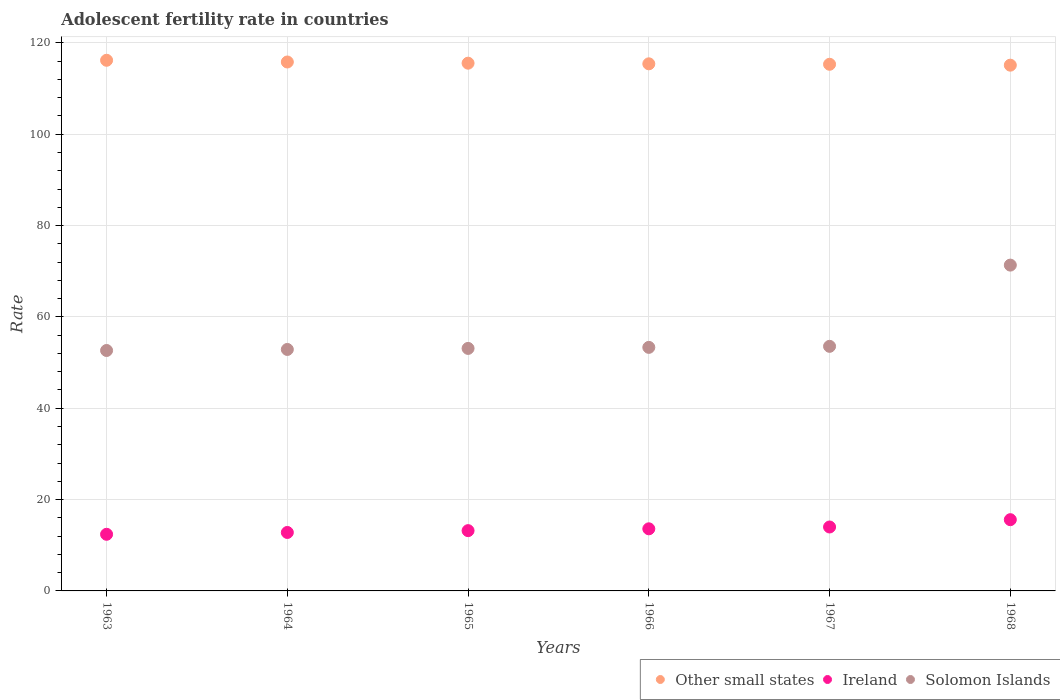How many different coloured dotlines are there?
Give a very brief answer. 3. Is the number of dotlines equal to the number of legend labels?
Offer a terse response. Yes. What is the adolescent fertility rate in Other small states in 1965?
Make the answer very short. 115.55. Across all years, what is the maximum adolescent fertility rate in Solomon Islands?
Keep it short and to the point. 71.34. Across all years, what is the minimum adolescent fertility rate in Ireland?
Ensure brevity in your answer.  12.4. In which year was the adolescent fertility rate in Other small states minimum?
Keep it short and to the point. 1968. What is the total adolescent fertility rate in Other small states in the graph?
Provide a short and direct response. 693.4. What is the difference between the adolescent fertility rate in Other small states in 1964 and that in 1966?
Your answer should be compact. 0.4. What is the difference between the adolescent fertility rate in Other small states in 1966 and the adolescent fertility rate in Ireland in 1964?
Make the answer very short. 102.61. What is the average adolescent fertility rate in Ireland per year?
Offer a terse response. 13.6. In the year 1968, what is the difference between the adolescent fertility rate in Other small states and adolescent fertility rate in Ireland?
Provide a succinct answer. 99.52. What is the ratio of the adolescent fertility rate in Ireland in 1963 to that in 1965?
Provide a succinct answer. 0.94. What is the difference between the highest and the second highest adolescent fertility rate in Solomon Islands?
Offer a terse response. 17.78. What is the difference between the highest and the lowest adolescent fertility rate in Ireland?
Keep it short and to the point. 3.2. How many years are there in the graph?
Your answer should be very brief. 6. Are the values on the major ticks of Y-axis written in scientific E-notation?
Ensure brevity in your answer.  No. Where does the legend appear in the graph?
Provide a succinct answer. Bottom right. How many legend labels are there?
Your answer should be compact. 3. What is the title of the graph?
Make the answer very short. Adolescent fertility rate in countries. What is the label or title of the X-axis?
Ensure brevity in your answer.  Years. What is the label or title of the Y-axis?
Your answer should be compact. Rate. What is the Rate of Other small states in 1963?
Give a very brief answer. 116.19. What is the Rate of Ireland in 1963?
Provide a short and direct response. 12.4. What is the Rate in Solomon Islands in 1963?
Your answer should be compact. 52.64. What is the Rate of Other small states in 1964?
Keep it short and to the point. 115.81. What is the Rate in Ireland in 1964?
Your answer should be compact. 12.8. What is the Rate in Solomon Islands in 1964?
Your answer should be compact. 52.87. What is the Rate of Other small states in 1965?
Make the answer very short. 115.55. What is the Rate of Ireland in 1965?
Your response must be concise. 13.2. What is the Rate in Solomon Islands in 1965?
Give a very brief answer. 53.1. What is the Rate in Other small states in 1966?
Your response must be concise. 115.41. What is the Rate of Ireland in 1966?
Offer a terse response. 13.6. What is the Rate in Solomon Islands in 1966?
Your answer should be compact. 53.33. What is the Rate of Other small states in 1967?
Give a very brief answer. 115.31. What is the Rate of Ireland in 1967?
Offer a terse response. 14. What is the Rate of Solomon Islands in 1967?
Your response must be concise. 53.55. What is the Rate of Other small states in 1968?
Make the answer very short. 115.12. What is the Rate in Ireland in 1968?
Offer a terse response. 15.6. What is the Rate in Solomon Islands in 1968?
Offer a terse response. 71.34. Across all years, what is the maximum Rate of Other small states?
Your answer should be very brief. 116.19. Across all years, what is the maximum Rate of Ireland?
Provide a short and direct response. 15.6. Across all years, what is the maximum Rate of Solomon Islands?
Give a very brief answer. 71.34. Across all years, what is the minimum Rate in Other small states?
Offer a terse response. 115.12. Across all years, what is the minimum Rate of Ireland?
Your response must be concise. 12.4. Across all years, what is the minimum Rate of Solomon Islands?
Give a very brief answer. 52.64. What is the total Rate of Other small states in the graph?
Provide a short and direct response. 693.4. What is the total Rate in Ireland in the graph?
Offer a terse response. 81.59. What is the total Rate in Solomon Islands in the graph?
Offer a terse response. 336.83. What is the difference between the Rate in Other small states in 1963 and that in 1964?
Give a very brief answer. 0.37. What is the difference between the Rate of Ireland in 1963 and that in 1964?
Offer a terse response. -0.4. What is the difference between the Rate in Solomon Islands in 1963 and that in 1964?
Keep it short and to the point. -0.23. What is the difference between the Rate of Other small states in 1963 and that in 1965?
Ensure brevity in your answer.  0.64. What is the difference between the Rate of Ireland in 1963 and that in 1965?
Ensure brevity in your answer.  -0.8. What is the difference between the Rate of Solomon Islands in 1963 and that in 1965?
Your answer should be very brief. -0.46. What is the difference between the Rate of Other small states in 1963 and that in 1966?
Ensure brevity in your answer.  0.77. What is the difference between the Rate of Ireland in 1963 and that in 1966?
Your answer should be very brief. -1.2. What is the difference between the Rate in Solomon Islands in 1963 and that in 1966?
Provide a succinct answer. -0.68. What is the difference between the Rate of Other small states in 1963 and that in 1967?
Offer a terse response. 0.88. What is the difference between the Rate in Ireland in 1963 and that in 1967?
Give a very brief answer. -1.6. What is the difference between the Rate in Solomon Islands in 1963 and that in 1967?
Your answer should be very brief. -0.91. What is the difference between the Rate of Other small states in 1963 and that in 1968?
Give a very brief answer. 1.07. What is the difference between the Rate in Ireland in 1963 and that in 1968?
Provide a short and direct response. -3.2. What is the difference between the Rate in Solomon Islands in 1963 and that in 1968?
Your answer should be very brief. -18.7. What is the difference between the Rate in Other small states in 1964 and that in 1965?
Make the answer very short. 0.26. What is the difference between the Rate of Ireland in 1964 and that in 1965?
Offer a terse response. -0.4. What is the difference between the Rate in Solomon Islands in 1964 and that in 1965?
Give a very brief answer. -0.23. What is the difference between the Rate in Other small states in 1964 and that in 1966?
Your answer should be very brief. 0.4. What is the difference between the Rate in Ireland in 1964 and that in 1966?
Provide a short and direct response. -0.8. What is the difference between the Rate of Solomon Islands in 1964 and that in 1966?
Keep it short and to the point. -0.46. What is the difference between the Rate in Other small states in 1964 and that in 1967?
Provide a succinct answer. 0.5. What is the difference between the Rate of Ireland in 1964 and that in 1967?
Keep it short and to the point. -1.2. What is the difference between the Rate of Solomon Islands in 1964 and that in 1967?
Provide a short and direct response. -0.68. What is the difference between the Rate of Other small states in 1964 and that in 1968?
Give a very brief answer. 0.7. What is the difference between the Rate in Ireland in 1964 and that in 1968?
Your response must be concise. -2.8. What is the difference between the Rate of Solomon Islands in 1964 and that in 1968?
Provide a short and direct response. -18.47. What is the difference between the Rate in Other small states in 1965 and that in 1966?
Give a very brief answer. 0.14. What is the difference between the Rate in Ireland in 1965 and that in 1966?
Offer a terse response. -0.4. What is the difference between the Rate in Solomon Islands in 1965 and that in 1966?
Provide a short and direct response. -0.23. What is the difference between the Rate of Other small states in 1965 and that in 1967?
Offer a terse response. 0.24. What is the difference between the Rate in Ireland in 1965 and that in 1967?
Your answer should be very brief. -0.8. What is the difference between the Rate in Solomon Islands in 1965 and that in 1967?
Your answer should be very brief. -0.46. What is the difference between the Rate of Other small states in 1965 and that in 1968?
Make the answer very short. 0.44. What is the difference between the Rate of Ireland in 1965 and that in 1968?
Provide a succinct answer. -2.4. What is the difference between the Rate of Solomon Islands in 1965 and that in 1968?
Offer a very short reply. -18.24. What is the difference between the Rate in Other small states in 1966 and that in 1967?
Offer a terse response. 0.1. What is the difference between the Rate of Ireland in 1966 and that in 1967?
Your response must be concise. -0.4. What is the difference between the Rate in Solomon Islands in 1966 and that in 1967?
Your response must be concise. -0.23. What is the difference between the Rate of Other small states in 1966 and that in 1968?
Offer a very short reply. 0.3. What is the difference between the Rate in Ireland in 1966 and that in 1968?
Keep it short and to the point. -2. What is the difference between the Rate of Solomon Islands in 1966 and that in 1968?
Provide a short and direct response. -18.01. What is the difference between the Rate in Other small states in 1967 and that in 1968?
Make the answer very short. 0.2. What is the difference between the Rate of Ireland in 1967 and that in 1968?
Provide a short and direct response. -1.6. What is the difference between the Rate of Solomon Islands in 1967 and that in 1968?
Offer a very short reply. -17.78. What is the difference between the Rate in Other small states in 1963 and the Rate in Ireland in 1964?
Offer a very short reply. 103.39. What is the difference between the Rate in Other small states in 1963 and the Rate in Solomon Islands in 1964?
Provide a short and direct response. 63.32. What is the difference between the Rate of Ireland in 1963 and the Rate of Solomon Islands in 1964?
Provide a short and direct response. -40.47. What is the difference between the Rate in Other small states in 1963 and the Rate in Ireland in 1965?
Give a very brief answer. 102.99. What is the difference between the Rate in Other small states in 1963 and the Rate in Solomon Islands in 1965?
Provide a short and direct response. 63.09. What is the difference between the Rate in Ireland in 1963 and the Rate in Solomon Islands in 1965?
Keep it short and to the point. -40.7. What is the difference between the Rate of Other small states in 1963 and the Rate of Ireland in 1966?
Provide a short and direct response. 102.59. What is the difference between the Rate of Other small states in 1963 and the Rate of Solomon Islands in 1966?
Provide a short and direct response. 62.86. What is the difference between the Rate of Ireland in 1963 and the Rate of Solomon Islands in 1966?
Offer a terse response. -40.93. What is the difference between the Rate of Other small states in 1963 and the Rate of Ireland in 1967?
Make the answer very short. 102.19. What is the difference between the Rate of Other small states in 1963 and the Rate of Solomon Islands in 1967?
Provide a short and direct response. 62.63. What is the difference between the Rate in Ireland in 1963 and the Rate in Solomon Islands in 1967?
Your answer should be very brief. -41.15. What is the difference between the Rate of Other small states in 1963 and the Rate of Ireland in 1968?
Offer a very short reply. 100.59. What is the difference between the Rate of Other small states in 1963 and the Rate of Solomon Islands in 1968?
Your answer should be very brief. 44.85. What is the difference between the Rate of Ireland in 1963 and the Rate of Solomon Islands in 1968?
Offer a very short reply. -58.94. What is the difference between the Rate in Other small states in 1964 and the Rate in Ireland in 1965?
Your answer should be compact. 102.61. What is the difference between the Rate of Other small states in 1964 and the Rate of Solomon Islands in 1965?
Your response must be concise. 62.71. What is the difference between the Rate of Ireland in 1964 and the Rate of Solomon Islands in 1965?
Make the answer very short. -40.3. What is the difference between the Rate in Other small states in 1964 and the Rate in Ireland in 1966?
Ensure brevity in your answer.  102.22. What is the difference between the Rate of Other small states in 1964 and the Rate of Solomon Islands in 1966?
Your response must be concise. 62.49. What is the difference between the Rate of Ireland in 1964 and the Rate of Solomon Islands in 1966?
Your response must be concise. -40.53. What is the difference between the Rate in Other small states in 1964 and the Rate in Ireland in 1967?
Your answer should be very brief. 101.82. What is the difference between the Rate in Other small states in 1964 and the Rate in Solomon Islands in 1967?
Provide a succinct answer. 62.26. What is the difference between the Rate of Ireland in 1964 and the Rate of Solomon Islands in 1967?
Provide a short and direct response. -40.75. What is the difference between the Rate in Other small states in 1964 and the Rate in Ireland in 1968?
Keep it short and to the point. 100.22. What is the difference between the Rate of Other small states in 1964 and the Rate of Solomon Islands in 1968?
Your answer should be very brief. 44.48. What is the difference between the Rate of Ireland in 1964 and the Rate of Solomon Islands in 1968?
Offer a terse response. -58.54. What is the difference between the Rate of Other small states in 1965 and the Rate of Ireland in 1966?
Your answer should be very brief. 101.95. What is the difference between the Rate in Other small states in 1965 and the Rate in Solomon Islands in 1966?
Provide a short and direct response. 62.23. What is the difference between the Rate in Ireland in 1965 and the Rate in Solomon Islands in 1966?
Provide a short and direct response. -40.13. What is the difference between the Rate in Other small states in 1965 and the Rate in Ireland in 1967?
Your response must be concise. 101.55. What is the difference between the Rate in Other small states in 1965 and the Rate in Solomon Islands in 1967?
Ensure brevity in your answer.  62. What is the difference between the Rate in Ireland in 1965 and the Rate in Solomon Islands in 1967?
Provide a short and direct response. -40.36. What is the difference between the Rate in Other small states in 1965 and the Rate in Ireland in 1968?
Provide a succinct answer. 99.95. What is the difference between the Rate of Other small states in 1965 and the Rate of Solomon Islands in 1968?
Offer a very short reply. 44.21. What is the difference between the Rate of Ireland in 1965 and the Rate of Solomon Islands in 1968?
Ensure brevity in your answer.  -58.14. What is the difference between the Rate in Other small states in 1966 and the Rate in Ireland in 1967?
Your response must be concise. 101.42. What is the difference between the Rate of Other small states in 1966 and the Rate of Solomon Islands in 1967?
Give a very brief answer. 61.86. What is the difference between the Rate of Ireland in 1966 and the Rate of Solomon Islands in 1967?
Provide a succinct answer. -39.96. What is the difference between the Rate in Other small states in 1966 and the Rate in Ireland in 1968?
Ensure brevity in your answer.  99.82. What is the difference between the Rate in Other small states in 1966 and the Rate in Solomon Islands in 1968?
Provide a short and direct response. 44.08. What is the difference between the Rate in Ireland in 1966 and the Rate in Solomon Islands in 1968?
Ensure brevity in your answer.  -57.74. What is the difference between the Rate of Other small states in 1967 and the Rate of Ireland in 1968?
Provide a succinct answer. 99.72. What is the difference between the Rate in Other small states in 1967 and the Rate in Solomon Islands in 1968?
Keep it short and to the point. 43.97. What is the difference between the Rate of Ireland in 1967 and the Rate of Solomon Islands in 1968?
Keep it short and to the point. -57.34. What is the average Rate of Other small states per year?
Ensure brevity in your answer.  115.57. What is the average Rate of Ireland per year?
Give a very brief answer. 13.6. What is the average Rate of Solomon Islands per year?
Provide a short and direct response. 56.14. In the year 1963, what is the difference between the Rate of Other small states and Rate of Ireland?
Keep it short and to the point. 103.79. In the year 1963, what is the difference between the Rate of Other small states and Rate of Solomon Islands?
Keep it short and to the point. 63.54. In the year 1963, what is the difference between the Rate of Ireland and Rate of Solomon Islands?
Your response must be concise. -40.24. In the year 1964, what is the difference between the Rate in Other small states and Rate in Ireland?
Your answer should be compact. 103.01. In the year 1964, what is the difference between the Rate of Other small states and Rate of Solomon Islands?
Your answer should be very brief. 62.94. In the year 1964, what is the difference between the Rate of Ireland and Rate of Solomon Islands?
Offer a very short reply. -40.07. In the year 1965, what is the difference between the Rate in Other small states and Rate in Ireland?
Your answer should be compact. 102.35. In the year 1965, what is the difference between the Rate in Other small states and Rate in Solomon Islands?
Provide a short and direct response. 62.45. In the year 1965, what is the difference between the Rate in Ireland and Rate in Solomon Islands?
Keep it short and to the point. -39.9. In the year 1966, what is the difference between the Rate in Other small states and Rate in Ireland?
Keep it short and to the point. 101.82. In the year 1966, what is the difference between the Rate in Other small states and Rate in Solomon Islands?
Ensure brevity in your answer.  62.09. In the year 1966, what is the difference between the Rate in Ireland and Rate in Solomon Islands?
Make the answer very short. -39.73. In the year 1967, what is the difference between the Rate of Other small states and Rate of Ireland?
Provide a succinct answer. 101.31. In the year 1967, what is the difference between the Rate of Other small states and Rate of Solomon Islands?
Your response must be concise. 61.76. In the year 1967, what is the difference between the Rate in Ireland and Rate in Solomon Islands?
Your response must be concise. -39.56. In the year 1968, what is the difference between the Rate of Other small states and Rate of Ireland?
Keep it short and to the point. 99.52. In the year 1968, what is the difference between the Rate of Other small states and Rate of Solomon Islands?
Keep it short and to the point. 43.78. In the year 1968, what is the difference between the Rate in Ireland and Rate in Solomon Islands?
Your response must be concise. -55.74. What is the ratio of the Rate of Other small states in 1963 to that in 1964?
Make the answer very short. 1. What is the ratio of the Rate in Ireland in 1963 to that in 1964?
Make the answer very short. 0.97. What is the ratio of the Rate of Ireland in 1963 to that in 1965?
Offer a very short reply. 0.94. What is the ratio of the Rate in Solomon Islands in 1963 to that in 1965?
Give a very brief answer. 0.99. What is the ratio of the Rate of Ireland in 1963 to that in 1966?
Keep it short and to the point. 0.91. What is the ratio of the Rate in Solomon Islands in 1963 to that in 1966?
Give a very brief answer. 0.99. What is the ratio of the Rate of Other small states in 1963 to that in 1967?
Your answer should be compact. 1.01. What is the ratio of the Rate in Ireland in 1963 to that in 1967?
Provide a short and direct response. 0.89. What is the ratio of the Rate of Other small states in 1963 to that in 1968?
Your response must be concise. 1.01. What is the ratio of the Rate of Ireland in 1963 to that in 1968?
Offer a terse response. 0.8. What is the ratio of the Rate of Solomon Islands in 1963 to that in 1968?
Your response must be concise. 0.74. What is the ratio of the Rate of Ireland in 1964 to that in 1965?
Your answer should be compact. 0.97. What is the ratio of the Rate in Other small states in 1964 to that in 1967?
Ensure brevity in your answer.  1. What is the ratio of the Rate in Ireland in 1964 to that in 1967?
Your answer should be very brief. 0.91. What is the ratio of the Rate in Solomon Islands in 1964 to that in 1967?
Your response must be concise. 0.99. What is the ratio of the Rate in Other small states in 1964 to that in 1968?
Provide a short and direct response. 1.01. What is the ratio of the Rate in Ireland in 1964 to that in 1968?
Offer a very short reply. 0.82. What is the ratio of the Rate in Solomon Islands in 1964 to that in 1968?
Offer a very short reply. 0.74. What is the ratio of the Rate in Ireland in 1965 to that in 1966?
Offer a terse response. 0.97. What is the ratio of the Rate of Solomon Islands in 1965 to that in 1966?
Offer a terse response. 1. What is the ratio of the Rate of Other small states in 1965 to that in 1967?
Provide a short and direct response. 1. What is the ratio of the Rate of Ireland in 1965 to that in 1967?
Offer a terse response. 0.94. What is the ratio of the Rate of Solomon Islands in 1965 to that in 1967?
Your answer should be very brief. 0.99. What is the ratio of the Rate of Ireland in 1965 to that in 1968?
Give a very brief answer. 0.85. What is the ratio of the Rate of Solomon Islands in 1965 to that in 1968?
Ensure brevity in your answer.  0.74. What is the ratio of the Rate of Ireland in 1966 to that in 1967?
Make the answer very short. 0.97. What is the ratio of the Rate of Solomon Islands in 1966 to that in 1967?
Keep it short and to the point. 1. What is the ratio of the Rate in Ireland in 1966 to that in 1968?
Keep it short and to the point. 0.87. What is the ratio of the Rate in Solomon Islands in 1966 to that in 1968?
Your response must be concise. 0.75. What is the ratio of the Rate of Ireland in 1967 to that in 1968?
Offer a terse response. 0.9. What is the ratio of the Rate of Solomon Islands in 1967 to that in 1968?
Keep it short and to the point. 0.75. What is the difference between the highest and the second highest Rate of Other small states?
Keep it short and to the point. 0.37. What is the difference between the highest and the second highest Rate in Ireland?
Offer a very short reply. 1.6. What is the difference between the highest and the second highest Rate in Solomon Islands?
Offer a very short reply. 17.78. What is the difference between the highest and the lowest Rate of Other small states?
Provide a short and direct response. 1.07. What is the difference between the highest and the lowest Rate of Ireland?
Ensure brevity in your answer.  3.2. What is the difference between the highest and the lowest Rate in Solomon Islands?
Your response must be concise. 18.7. 